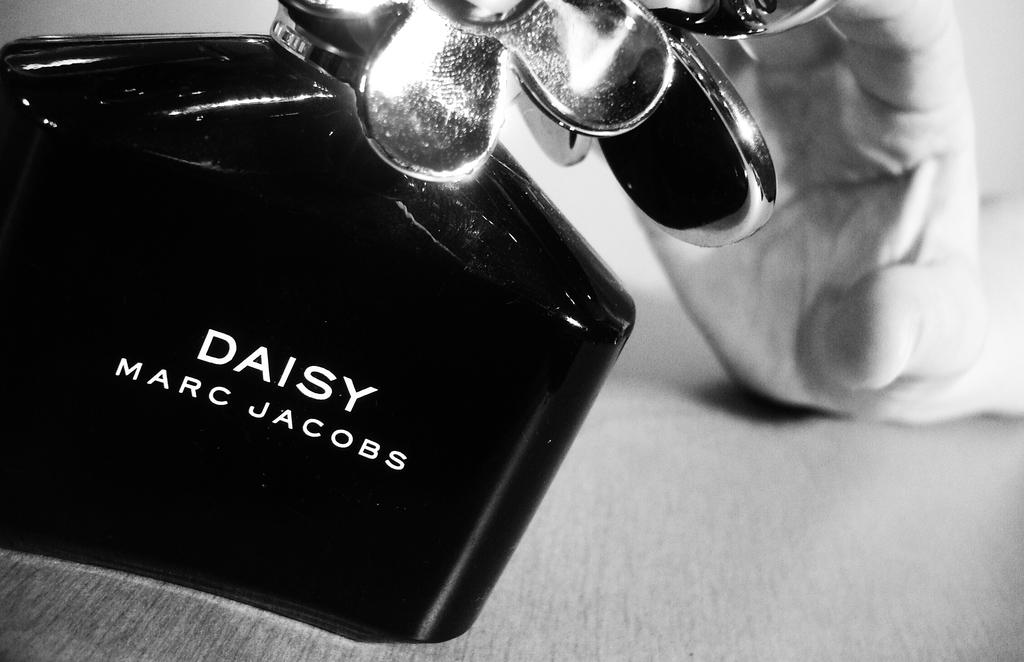Provide a one-sentence caption for the provided image. A bottle of perfume by Marc Jacobs with a hand behind it. 